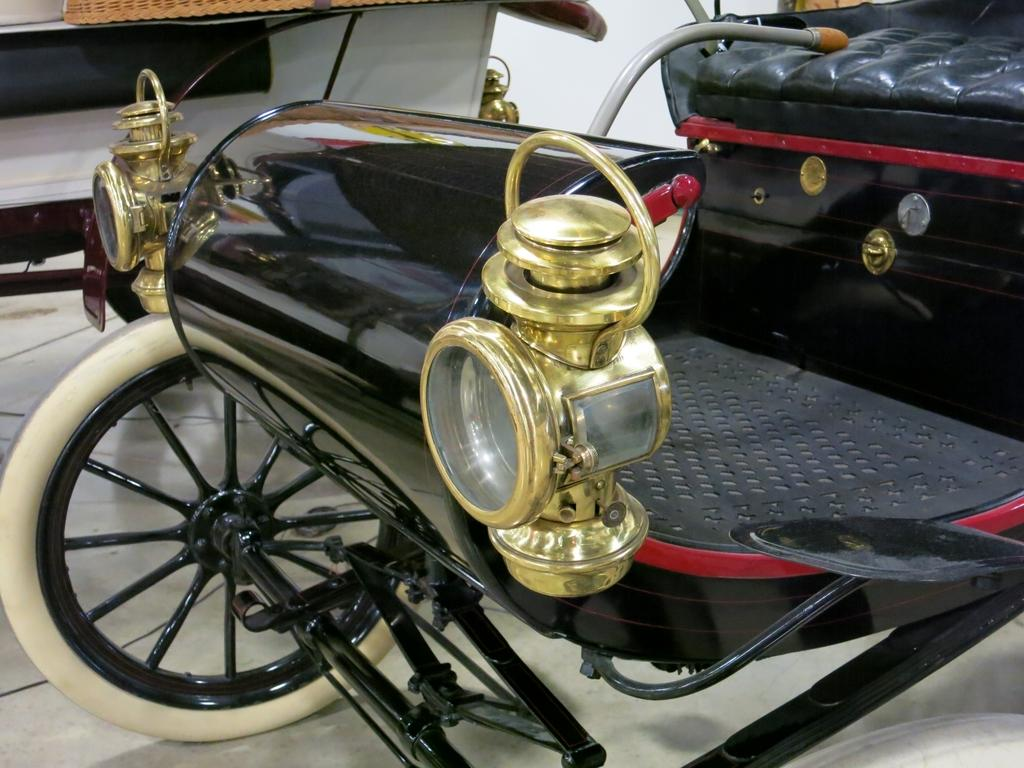Where was the image taken? The image is taken indoors. What can be seen under the vehicles in the image? There is a floor visible in the image. How many vehicles are parked in the image? Two vehicles are parked on the floor in the image. What type of celery is being used to wax the vehicles in the image? There is no celery or waxing activity present in the image; it features two vehicles parked on a floor indoors. What record is being played on the vehicles in the image? There is no record player or music playing in the image; it only shows two vehicles parked on a floor indoors. 